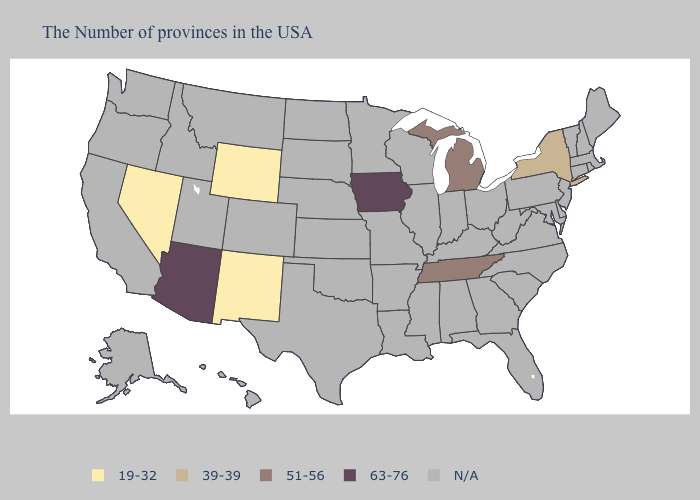What is the highest value in states that border Montana?
Give a very brief answer. 19-32. Name the states that have a value in the range 63-76?
Quick response, please. Iowa, Arizona. Which states hav the highest value in the Northeast?
Be succinct. New York. What is the highest value in the USA?
Give a very brief answer. 63-76. What is the value of Ohio?
Concise answer only. N/A. Name the states that have a value in the range N/A?
Quick response, please. Maine, Massachusetts, Rhode Island, New Hampshire, Vermont, Connecticut, New Jersey, Delaware, Maryland, Pennsylvania, Virginia, North Carolina, South Carolina, West Virginia, Ohio, Florida, Georgia, Kentucky, Indiana, Alabama, Wisconsin, Illinois, Mississippi, Louisiana, Missouri, Arkansas, Minnesota, Kansas, Nebraska, Oklahoma, Texas, South Dakota, North Dakota, Colorado, Utah, Montana, Idaho, California, Washington, Oregon, Alaska, Hawaii. Does the map have missing data?
Give a very brief answer. Yes. Does the map have missing data?
Give a very brief answer. Yes. What is the value of Tennessee?
Be succinct. 51-56. What is the value of Minnesota?
Answer briefly. N/A. Name the states that have a value in the range N/A?
Concise answer only. Maine, Massachusetts, Rhode Island, New Hampshire, Vermont, Connecticut, New Jersey, Delaware, Maryland, Pennsylvania, Virginia, North Carolina, South Carolina, West Virginia, Ohio, Florida, Georgia, Kentucky, Indiana, Alabama, Wisconsin, Illinois, Mississippi, Louisiana, Missouri, Arkansas, Minnesota, Kansas, Nebraska, Oklahoma, Texas, South Dakota, North Dakota, Colorado, Utah, Montana, Idaho, California, Washington, Oregon, Alaska, Hawaii. Does Michigan have the highest value in the MidWest?
Keep it brief. No. What is the value of Alaska?
Concise answer only. N/A. Is the legend a continuous bar?
Give a very brief answer. No. Name the states that have a value in the range N/A?
Answer briefly. Maine, Massachusetts, Rhode Island, New Hampshire, Vermont, Connecticut, New Jersey, Delaware, Maryland, Pennsylvania, Virginia, North Carolina, South Carolina, West Virginia, Ohio, Florida, Georgia, Kentucky, Indiana, Alabama, Wisconsin, Illinois, Mississippi, Louisiana, Missouri, Arkansas, Minnesota, Kansas, Nebraska, Oklahoma, Texas, South Dakota, North Dakota, Colorado, Utah, Montana, Idaho, California, Washington, Oregon, Alaska, Hawaii. 